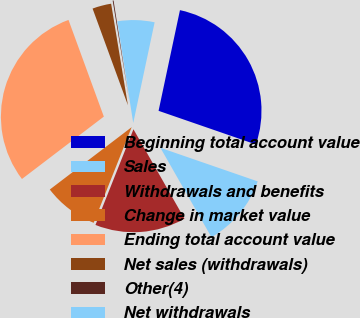<chart> <loc_0><loc_0><loc_500><loc_500><pie_chart><fcel>Beginning total account value<fcel>Sales<fcel>Withdrawals and benefits<fcel>Change in market value<fcel>Ending total account value<fcel>Net sales (withdrawals)<fcel>Other(4)<fcel>Net withdrawals<nl><fcel>26.96%<fcel>11.45%<fcel>14.27%<fcel>8.62%<fcel>29.78%<fcel>2.97%<fcel>0.14%<fcel>5.8%<nl></chart> 